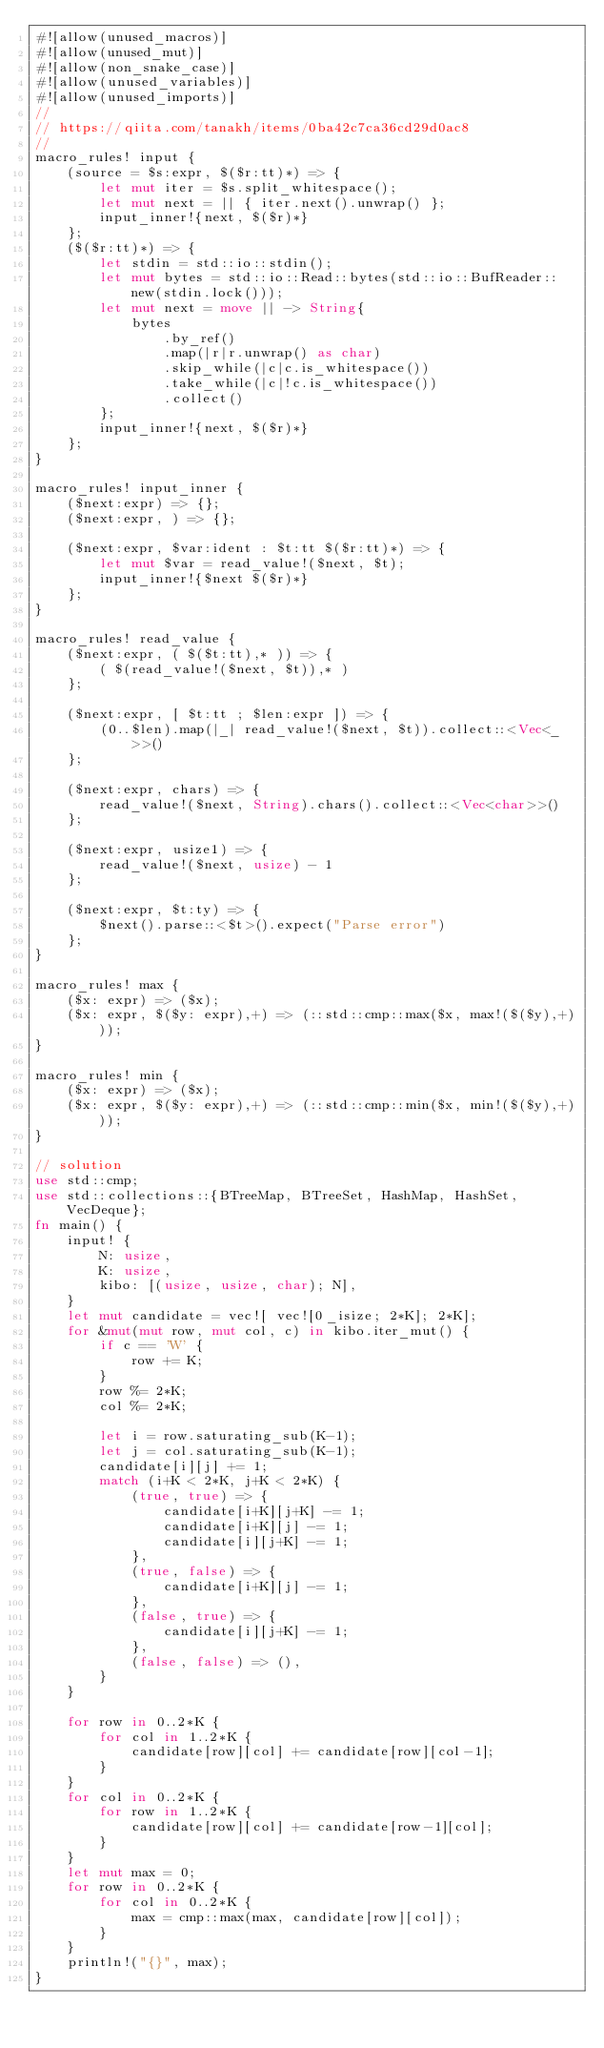<code> <loc_0><loc_0><loc_500><loc_500><_Rust_>#![allow(unused_macros)]
#![allow(unused_mut)]
#![allow(non_snake_case)]
#![allow(unused_variables)]
#![allow(unused_imports)]
//
// https://qiita.com/tanakh/items/0ba42c7ca36cd29d0ac8
//
macro_rules! input {
    (source = $s:expr, $($r:tt)*) => {
        let mut iter = $s.split_whitespace();
        let mut next = || { iter.next().unwrap() };
        input_inner!{next, $($r)*}
    };
    ($($r:tt)*) => {
        let stdin = std::io::stdin();
        let mut bytes = std::io::Read::bytes(std::io::BufReader::new(stdin.lock()));
        let mut next = move || -> String{
            bytes
                .by_ref()
                .map(|r|r.unwrap() as char)
                .skip_while(|c|c.is_whitespace())
                .take_while(|c|!c.is_whitespace())
                .collect()
        };
        input_inner!{next, $($r)*}
    };
}

macro_rules! input_inner {
    ($next:expr) => {};
    ($next:expr, ) => {};

    ($next:expr, $var:ident : $t:tt $($r:tt)*) => {
        let mut $var = read_value!($next, $t);
        input_inner!{$next $($r)*}
    };
}

macro_rules! read_value {
    ($next:expr, ( $($t:tt),* )) => {
        ( $(read_value!($next, $t)),* )
    };

    ($next:expr, [ $t:tt ; $len:expr ]) => {
        (0..$len).map(|_| read_value!($next, $t)).collect::<Vec<_>>()
    };

    ($next:expr, chars) => {
        read_value!($next, String).chars().collect::<Vec<char>>()
    };

    ($next:expr, usize1) => {
        read_value!($next, usize) - 1
    };

    ($next:expr, $t:ty) => {
        $next().parse::<$t>().expect("Parse error")
    };
}

macro_rules! max {
    ($x: expr) => ($x);
    ($x: expr, $($y: expr),+) => (::std::cmp::max($x, max!($($y),+)));
}

macro_rules! min {
    ($x: expr) => ($x);
    ($x: expr, $($y: expr),+) => (::std::cmp::min($x, min!($($y),+)));
}

// solution
use std::cmp;
use std::collections::{BTreeMap, BTreeSet, HashMap, HashSet, VecDeque};
fn main() {
    input! {
        N: usize,
        K: usize,
        kibo: [(usize, usize, char); N],
    }
    let mut candidate = vec![ vec![0_isize; 2*K]; 2*K];
    for &mut(mut row, mut col, c) in kibo.iter_mut() {
        if c == 'W' {
            row += K;
        }
        row %= 2*K;
        col %= 2*K;

        let i = row.saturating_sub(K-1);
        let j = col.saturating_sub(K-1);
        candidate[i][j] += 1;
        match (i+K < 2*K, j+K < 2*K) {
            (true, true) => {
                candidate[i+K][j+K] -= 1;
                candidate[i+K][j] -= 1;
                candidate[i][j+K] -= 1;
            },
            (true, false) => {
                candidate[i+K][j] -= 1;
            },
            (false, true) => {
                candidate[i][j+K] -= 1;
            },
            (false, false) => (),
        }
    }

    for row in 0..2*K {
        for col in 1..2*K {
            candidate[row][col] += candidate[row][col-1];
        }
    }
    for col in 0..2*K {
        for row in 1..2*K {
            candidate[row][col] += candidate[row-1][col];
        }
    }
    let mut max = 0;
    for row in 0..2*K {
        for col in 0..2*K {
            max = cmp::max(max, candidate[row][col]);
        }
    }
    println!("{}", max);
}
</code> 